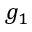Convert formula to latex. <formula><loc_0><loc_0><loc_500><loc_500>g _ { 1 }</formula> 